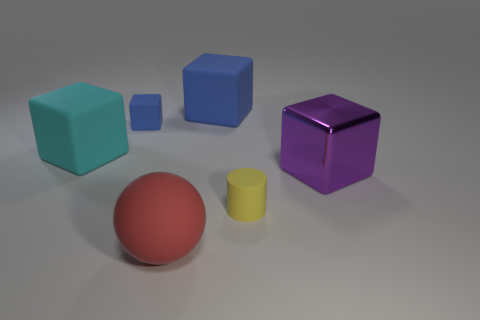Which object stands out the most due to its color and why? The red sphere stands out the most because its color contrasts sharply with the muted colors of the other objects and the neutral background. Red is also a color that typically draws attention in visual compositions. How is the lighting affecting the appearance of the objects? The lighting in the image is coming from an overhead source, creating soft shadows directly under the objects. It enhances the three-dimensional effect and gives a vivid appearance to the objects, highlighting their shapes and the reflective quality of the purple cube. 